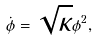<formula> <loc_0><loc_0><loc_500><loc_500>\dot { \phi } = \sqrt { \kappa } \phi ^ { 2 } ,</formula> 